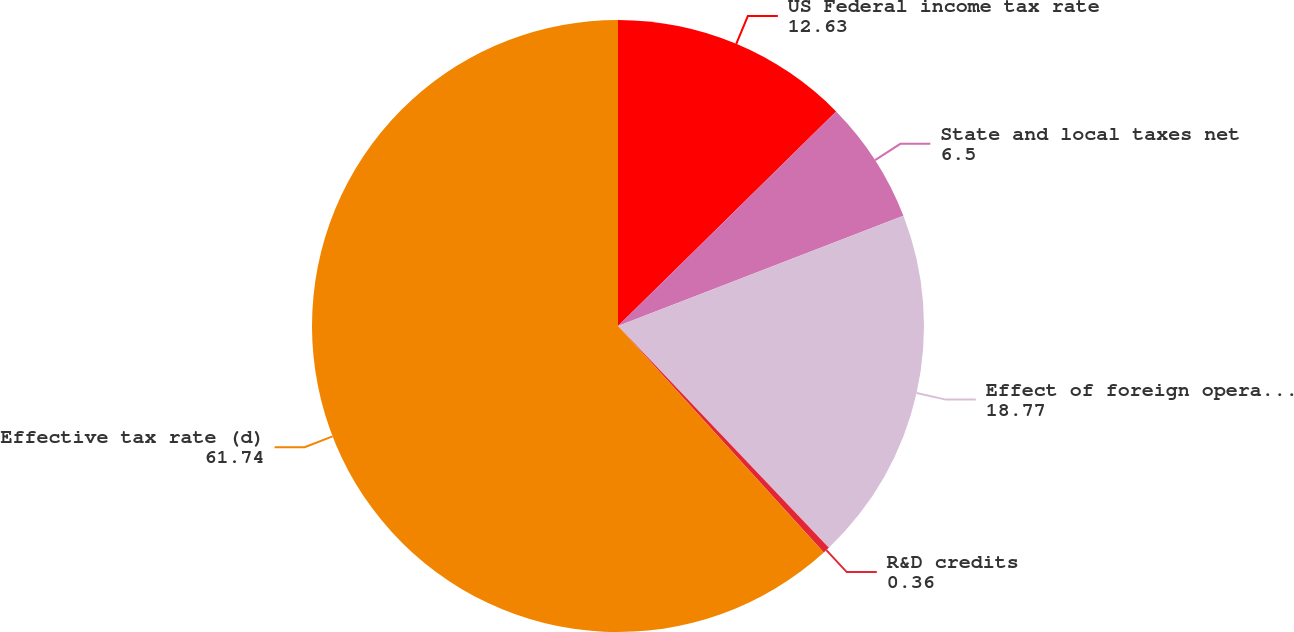Convert chart. <chart><loc_0><loc_0><loc_500><loc_500><pie_chart><fcel>US Federal income tax rate<fcel>State and local taxes net<fcel>Effect of foreign operations<fcel>R&D credits<fcel>Effective tax rate (d)<nl><fcel>12.63%<fcel>6.5%<fcel>18.77%<fcel>0.36%<fcel>61.74%<nl></chart> 